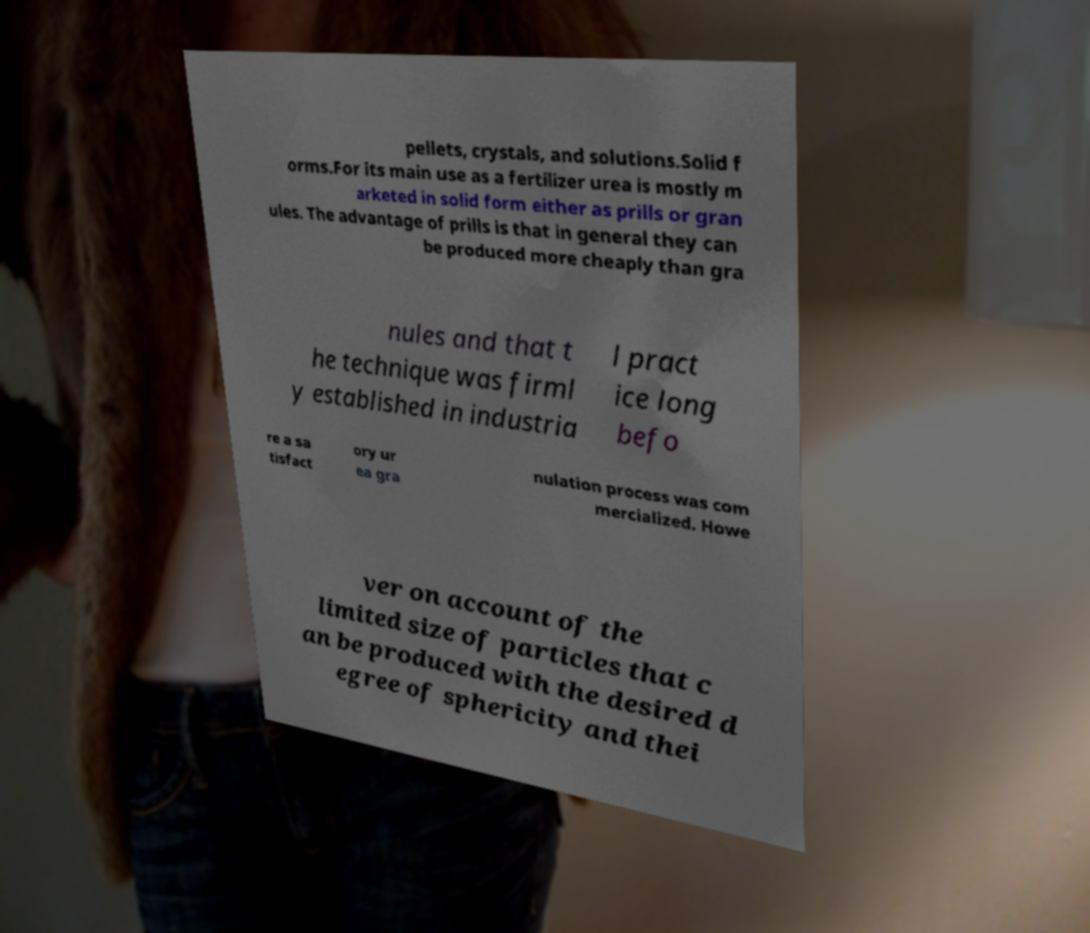Can you read and provide the text displayed in the image?This photo seems to have some interesting text. Can you extract and type it out for me? pellets, crystals, and solutions.Solid f orms.For its main use as a fertilizer urea is mostly m arketed in solid form either as prills or gran ules. The advantage of prills is that in general they can be produced more cheaply than gra nules and that t he technique was firml y established in industria l pract ice long befo re a sa tisfact ory ur ea gra nulation process was com mercialized. Howe ver on account of the limited size of particles that c an be produced with the desired d egree of sphericity and thei 